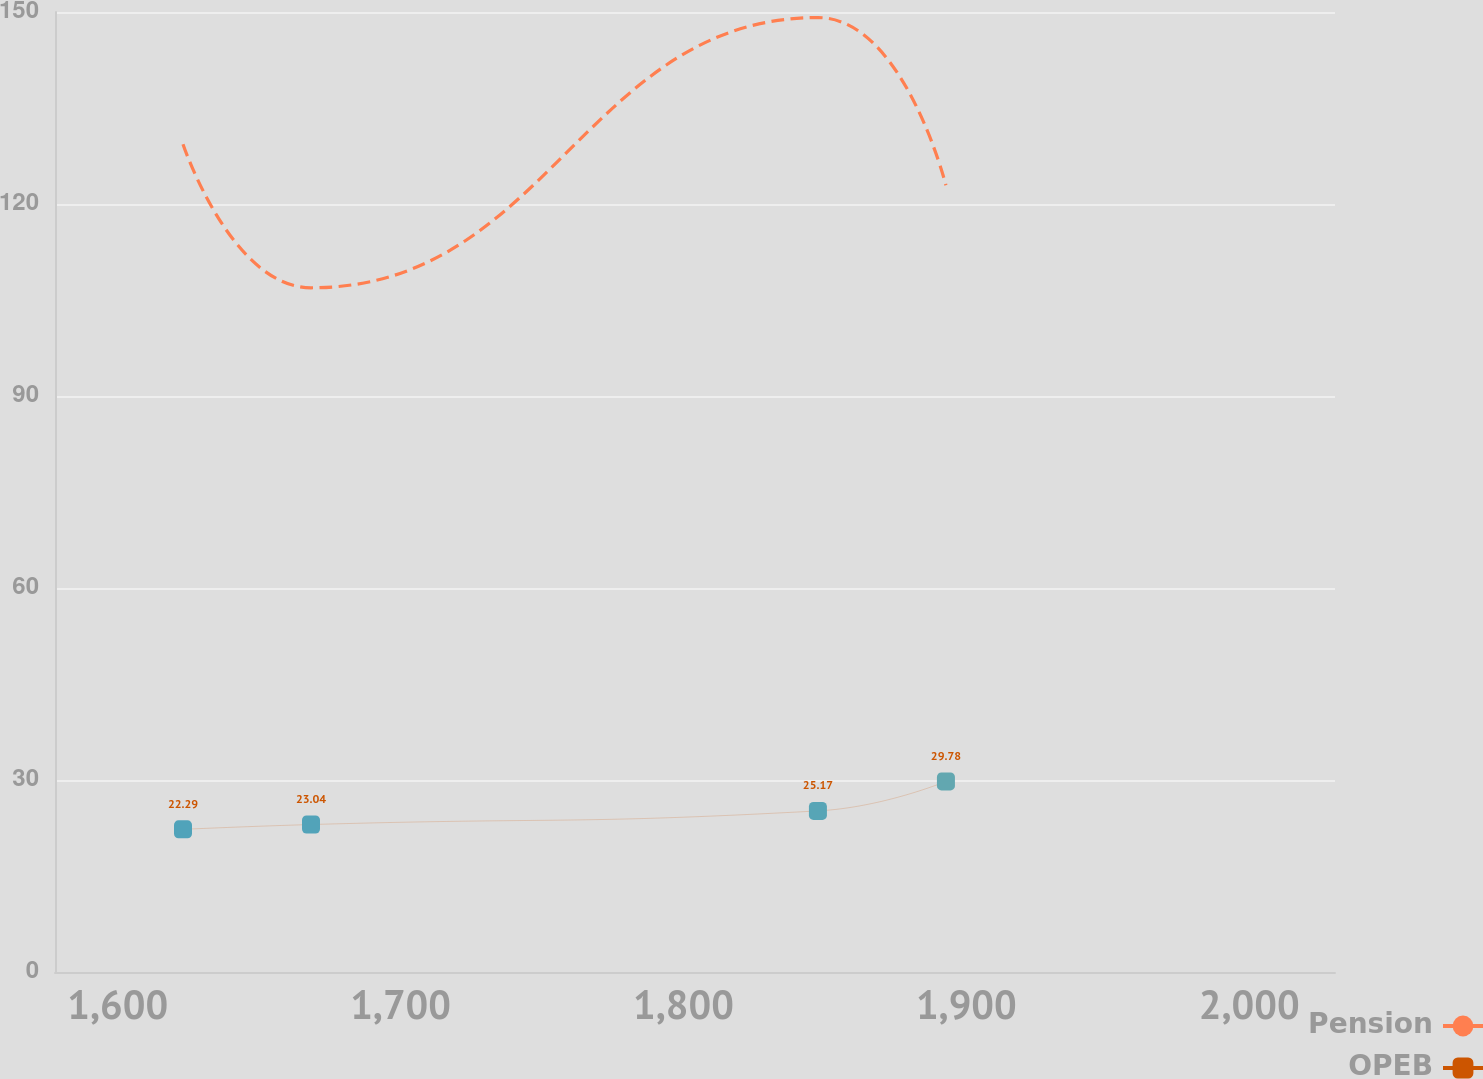<chart> <loc_0><loc_0><loc_500><loc_500><line_chart><ecel><fcel>Pension<fcel>OPEB<nl><fcel>1623.09<fcel>129.34<fcel>22.29<nl><fcel>1668.34<fcel>106.91<fcel>23.04<nl><fcel>1847.54<fcel>149.13<fcel>25.17<nl><fcel>1892.79<fcel>122.93<fcel>29.78<nl><fcel>2075.58<fcel>116.66<fcel>28.54<nl></chart> 